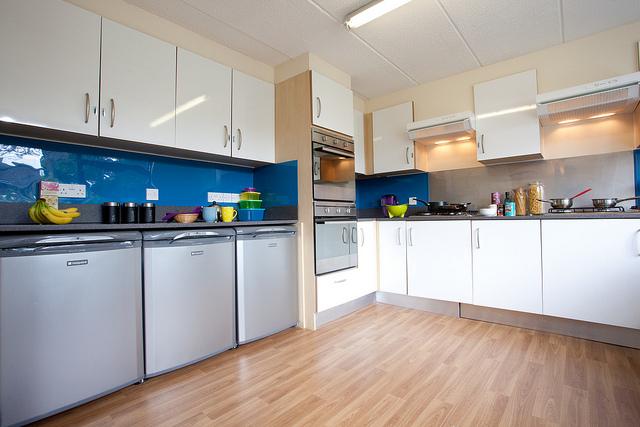Are the lights on in this room?
Answer briefly. Yes. Which room is this?
Be succinct. Kitchen. How many cabinets are there?
Short answer required. 13. 